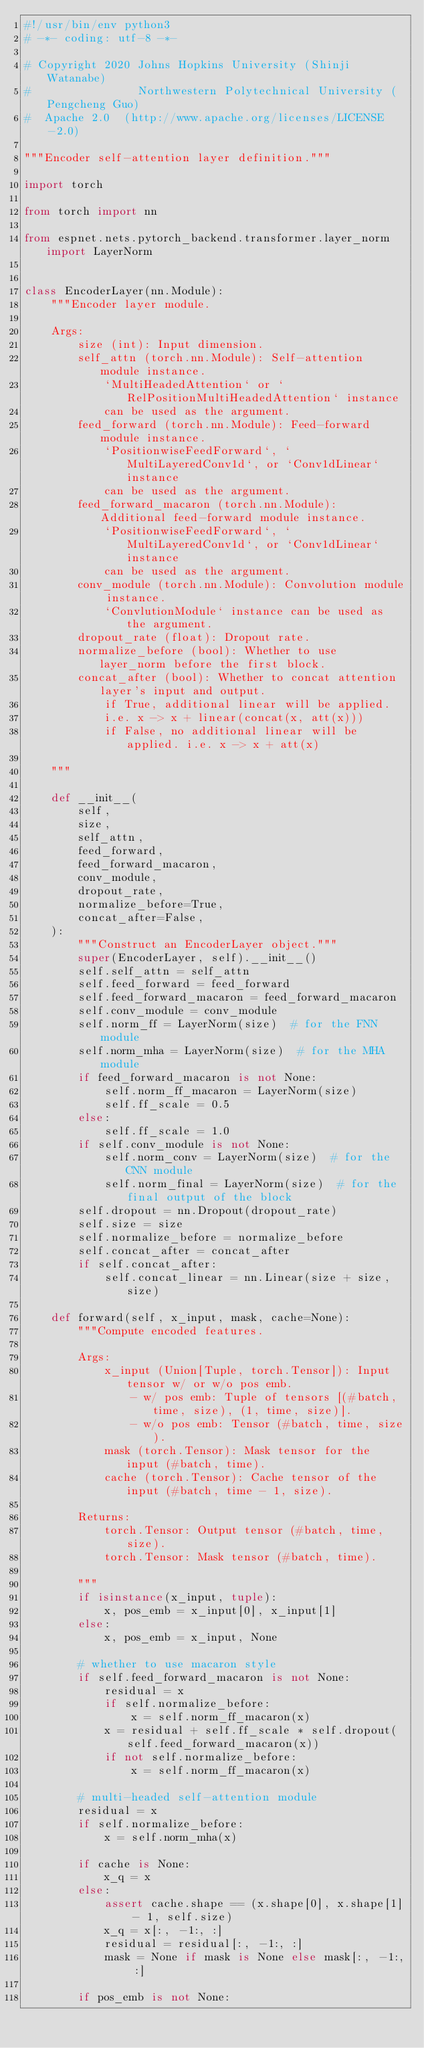Convert code to text. <code><loc_0><loc_0><loc_500><loc_500><_Python_>#!/usr/bin/env python3
# -*- coding: utf-8 -*-

# Copyright 2020 Johns Hopkins University (Shinji Watanabe)
#                Northwestern Polytechnical University (Pengcheng Guo)
#  Apache 2.0  (http://www.apache.org/licenses/LICENSE-2.0)

"""Encoder self-attention layer definition."""

import torch

from torch import nn

from espnet.nets.pytorch_backend.transformer.layer_norm import LayerNorm


class EncoderLayer(nn.Module):
    """Encoder layer module.

    Args:
        size (int): Input dimension.
        self_attn (torch.nn.Module): Self-attention module instance.
            `MultiHeadedAttention` or `RelPositionMultiHeadedAttention` instance
            can be used as the argument.
        feed_forward (torch.nn.Module): Feed-forward module instance.
            `PositionwiseFeedForward`, `MultiLayeredConv1d`, or `Conv1dLinear` instance
            can be used as the argument.
        feed_forward_macaron (torch.nn.Module): Additional feed-forward module instance.
            `PositionwiseFeedForward`, `MultiLayeredConv1d`, or `Conv1dLinear` instance
            can be used as the argument.
        conv_module (torch.nn.Module): Convolution module instance.
            `ConvlutionModule` instance can be used as the argument.
        dropout_rate (float): Dropout rate.
        normalize_before (bool): Whether to use layer_norm before the first block.
        concat_after (bool): Whether to concat attention layer's input and output.
            if True, additional linear will be applied.
            i.e. x -> x + linear(concat(x, att(x)))
            if False, no additional linear will be applied. i.e. x -> x + att(x)

    """

    def __init__(
        self,
        size,
        self_attn,
        feed_forward,
        feed_forward_macaron,
        conv_module,
        dropout_rate,
        normalize_before=True,
        concat_after=False,
    ):
        """Construct an EncoderLayer object."""
        super(EncoderLayer, self).__init__()
        self.self_attn = self_attn
        self.feed_forward = feed_forward
        self.feed_forward_macaron = feed_forward_macaron
        self.conv_module = conv_module
        self.norm_ff = LayerNorm(size)  # for the FNN module
        self.norm_mha = LayerNorm(size)  # for the MHA module
        if feed_forward_macaron is not None:
            self.norm_ff_macaron = LayerNorm(size)
            self.ff_scale = 0.5
        else:
            self.ff_scale = 1.0
        if self.conv_module is not None:
            self.norm_conv = LayerNorm(size)  # for the CNN module
            self.norm_final = LayerNorm(size)  # for the final output of the block
        self.dropout = nn.Dropout(dropout_rate)
        self.size = size
        self.normalize_before = normalize_before
        self.concat_after = concat_after
        if self.concat_after:
            self.concat_linear = nn.Linear(size + size, size)

    def forward(self, x_input, mask, cache=None):
        """Compute encoded features.

        Args:
            x_input (Union[Tuple, torch.Tensor]): Input tensor w/ or w/o pos emb.
                - w/ pos emb: Tuple of tensors [(#batch, time, size), (1, time, size)].
                - w/o pos emb: Tensor (#batch, time, size).
            mask (torch.Tensor): Mask tensor for the input (#batch, time).
            cache (torch.Tensor): Cache tensor of the input (#batch, time - 1, size).

        Returns:
            torch.Tensor: Output tensor (#batch, time, size).
            torch.Tensor: Mask tensor (#batch, time).

        """
        if isinstance(x_input, tuple):
            x, pos_emb = x_input[0], x_input[1]
        else:
            x, pos_emb = x_input, None

        # whether to use macaron style
        if self.feed_forward_macaron is not None:
            residual = x
            if self.normalize_before:
                x = self.norm_ff_macaron(x)
            x = residual + self.ff_scale * self.dropout(self.feed_forward_macaron(x))
            if not self.normalize_before:
                x = self.norm_ff_macaron(x)

        # multi-headed self-attention module
        residual = x
        if self.normalize_before:
            x = self.norm_mha(x)

        if cache is None:
            x_q = x
        else:
            assert cache.shape == (x.shape[0], x.shape[1] - 1, self.size)
            x_q = x[:, -1:, :]
            residual = residual[:, -1:, :]
            mask = None if mask is None else mask[:, -1:, :]

        if pos_emb is not None:</code> 